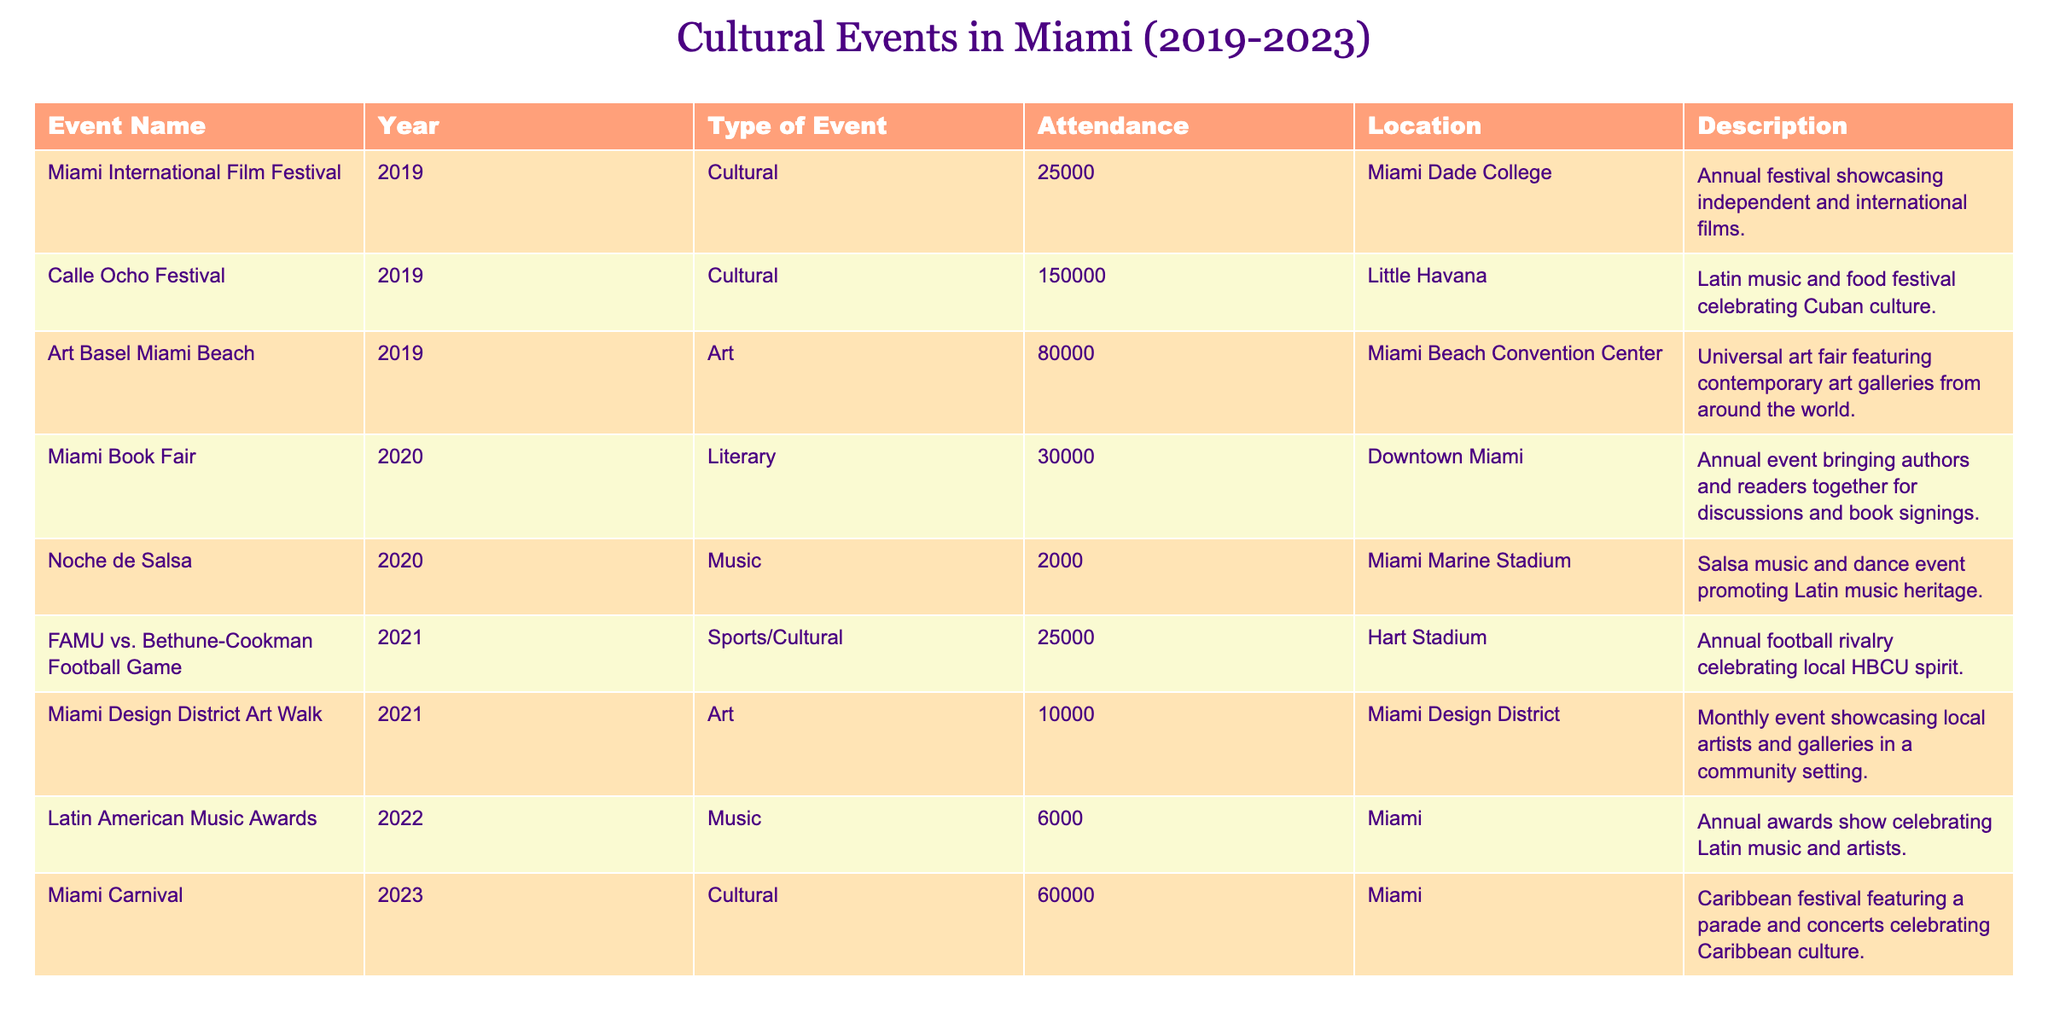What is the attendance figure for the Calle Ocho Festival in 2019? The table shows an entry for the Calle Ocho Festival under the Year 2019, where the attendance is listed as 150000.
Answer: 150000 Which event had the highest attendance in the past five years? Scanning through the attendance figures, the Calle Ocho Festival in 2019 stands out as having the highest attendance, which is 150000.
Answer: Calle Ocho Festival (2019) What was the total attendance for cultural events in 2020? To find the total attendance for cultural events in 2020, we need to sum the attendance figures for the Miami Book Fair (30000) and Noche de Salsa (2000). Therefore, the total attendance is 30000 + 2000 = 32000.
Answer: 32000 Was there an event in 2022 that celebrated Latin music? The table indicates that the Latin American Music Awards took place in 2022 and celebrates Latin music, confirming the presence of such an event for that year.
Answer: Yes What was the average attendance across all events listed from 2019 to 2023? First, add up the attendance figures: 25000 + 150000 + 80000 + 30000 + 2000 + 25000 + 10000 + 6000 + 60000 = 296000. There are a total of 9 events. To find the average, divide the total attendance by the number of events: 296000 / 9 = 32888.89.
Answer: 32888.89 How many events were held at the Miami Marine Stadium? The table lists only one event at the Miami Marine Stadium, which is Noche de Salsa in 2020.
Answer: 1 Which year saw the Miami Carnival and what was its attendance? The Miami Carnival took place in 2023, and it had an attendance of 60000, as specified in the table.
Answer: 2023, 60000 Was Art Basel Miami Beach held in 2020? Checking the table, Art Basel Miami Beach is listed under 2019, confirming that it was not held in 2020.
Answer: No 